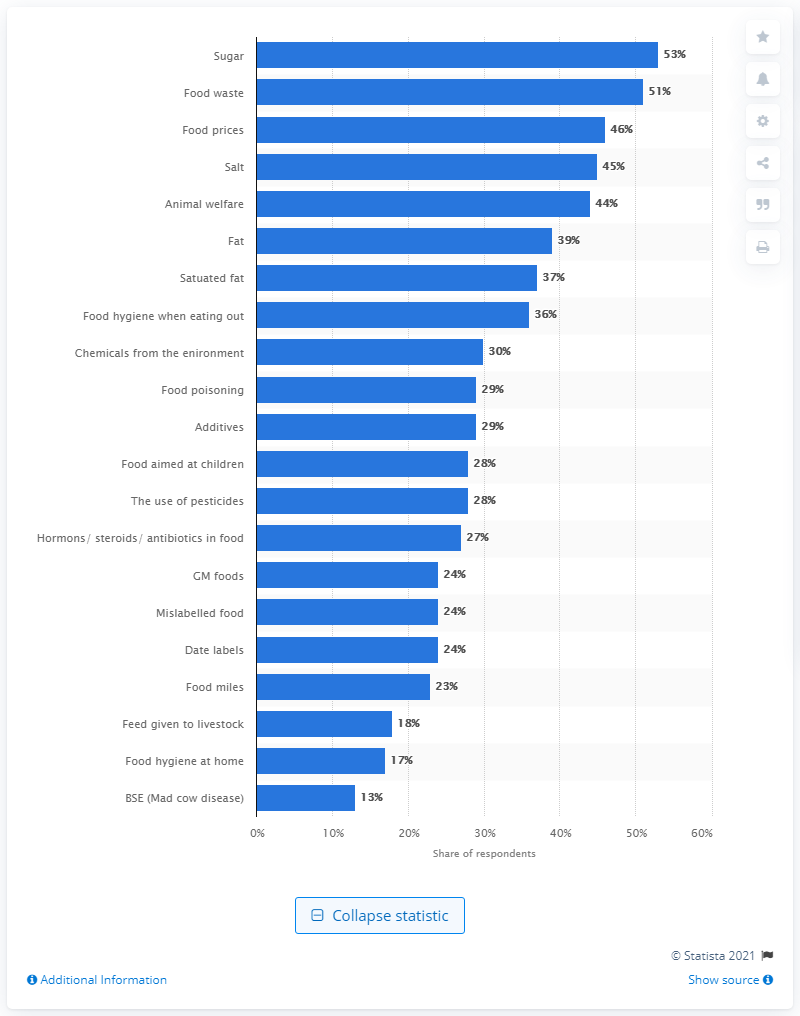Identify some key points in this picture. A significant proportion of individuals expressed concern about the amount of sugar in their food, with 53% reporting worry. 